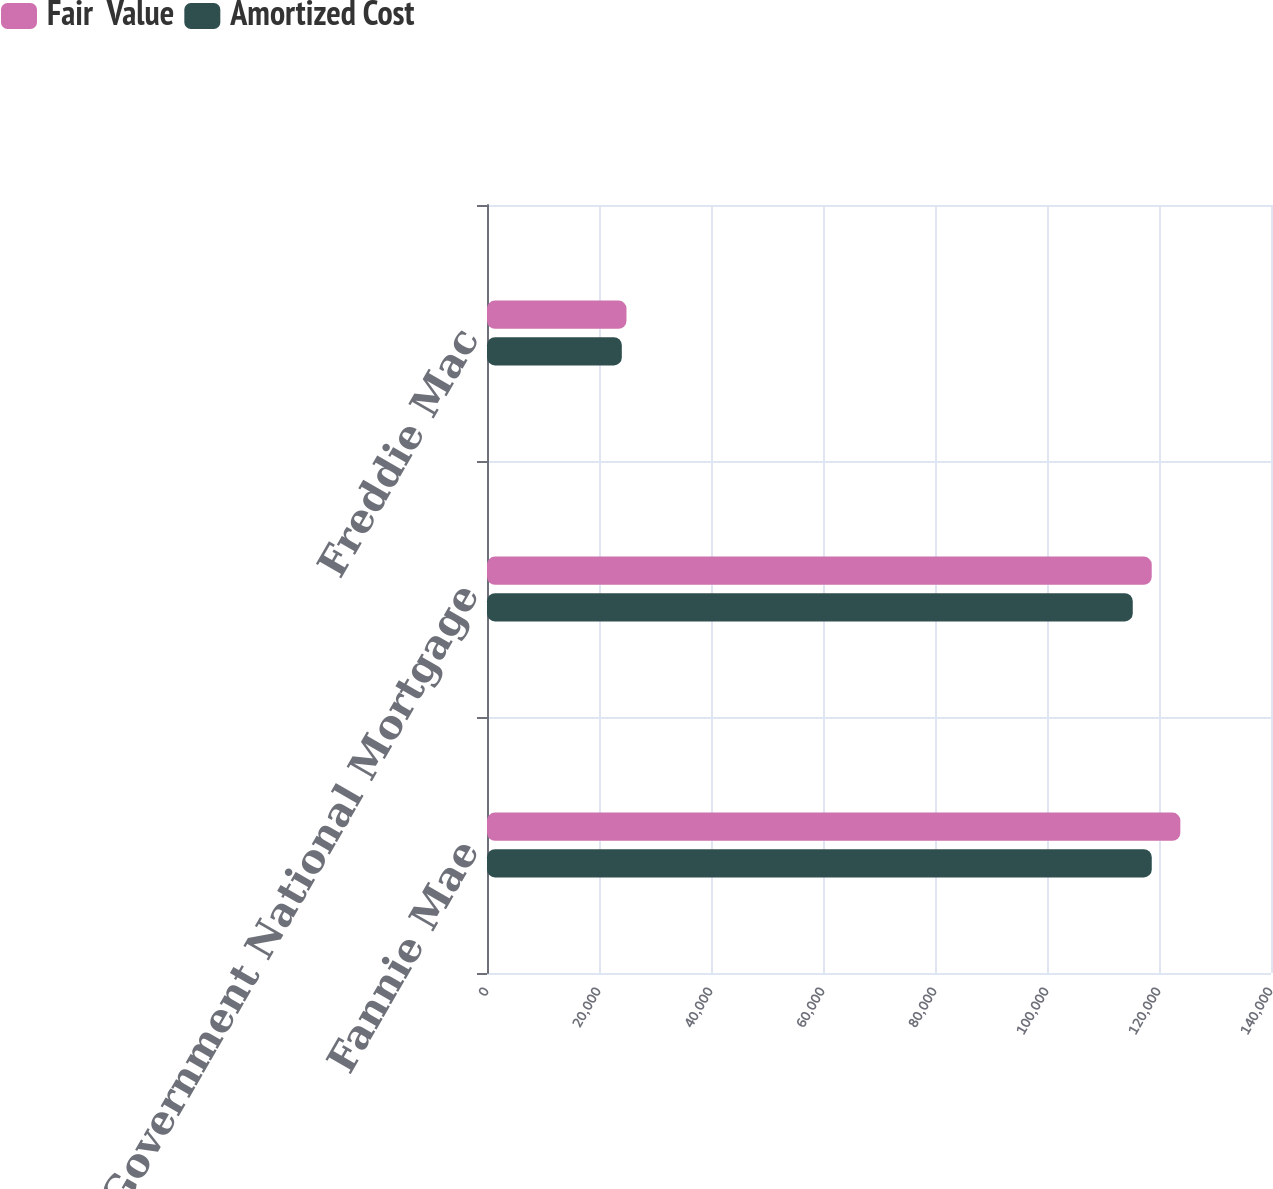Convert chart. <chart><loc_0><loc_0><loc_500><loc_500><stacked_bar_chart><ecel><fcel>Fannie Mae<fcel>Government National Mortgage<fcel>Freddie Mac<nl><fcel>Fair  Value<fcel>123813<fcel>118700<fcel>24908<nl><fcel>Amortized Cost<fcel>118708<fcel>115314<fcel>24075<nl></chart> 